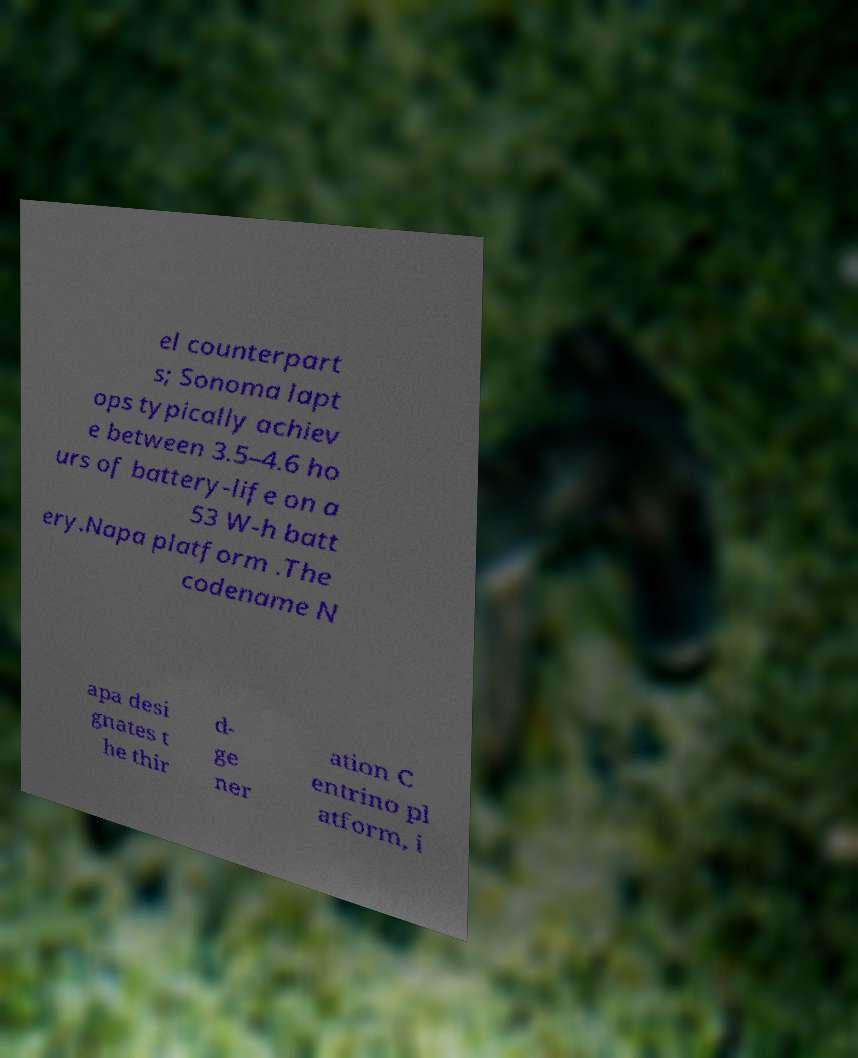Can you accurately transcribe the text from the provided image for me? el counterpart s; Sonoma lapt ops typically achiev e between 3.5–4.6 ho urs of battery-life on a 53 W-h batt ery.Napa platform .The codename N apa desi gnates t he thir d- ge ner ation C entrino pl atform, i 